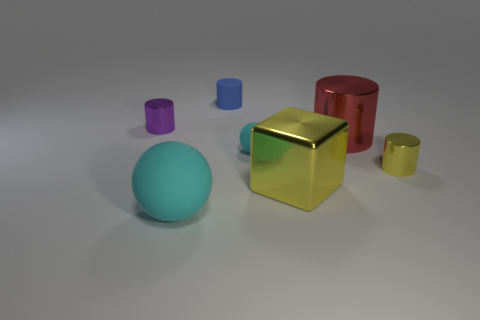Which objects in the image would fit together to form a pattern? The blue sphere, purple cylinder, and yellow cube share a similar size and glossy texture that if grouped together, would create an aesthetically pleasing pattern based on their shapes and reflective surfaces. 